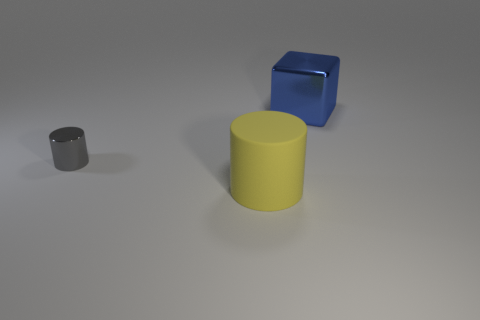Is there anything else that is the same material as the big yellow cylinder?
Your answer should be compact. No. What color is the shiny object in front of the large object behind the gray shiny cylinder?
Provide a short and direct response. Gray. What color is the shiny block that is the same size as the yellow rubber cylinder?
Provide a short and direct response. Blue. Are the big object that is to the right of the yellow rubber cylinder and the small gray object made of the same material?
Keep it short and to the point. Yes. There is a thing behind the cylinder that is on the left side of the large yellow rubber cylinder; is there a large rubber object to the left of it?
Give a very brief answer. Yes. There is a big object that is in front of the gray shiny cylinder; is its shape the same as the small shiny object?
Make the answer very short. Yes. There is a object right of the big object that is left of the large blue metal block; what is its shape?
Your response must be concise. Cube. There is a cylinder that is in front of the cylinder that is behind the cylinder that is in front of the small gray metallic cylinder; what is its size?
Provide a short and direct response. Large. What color is the other small shiny object that is the same shape as the yellow thing?
Ensure brevity in your answer.  Gray. Do the yellow rubber cylinder and the gray cylinder have the same size?
Provide a succinct answer. No. 